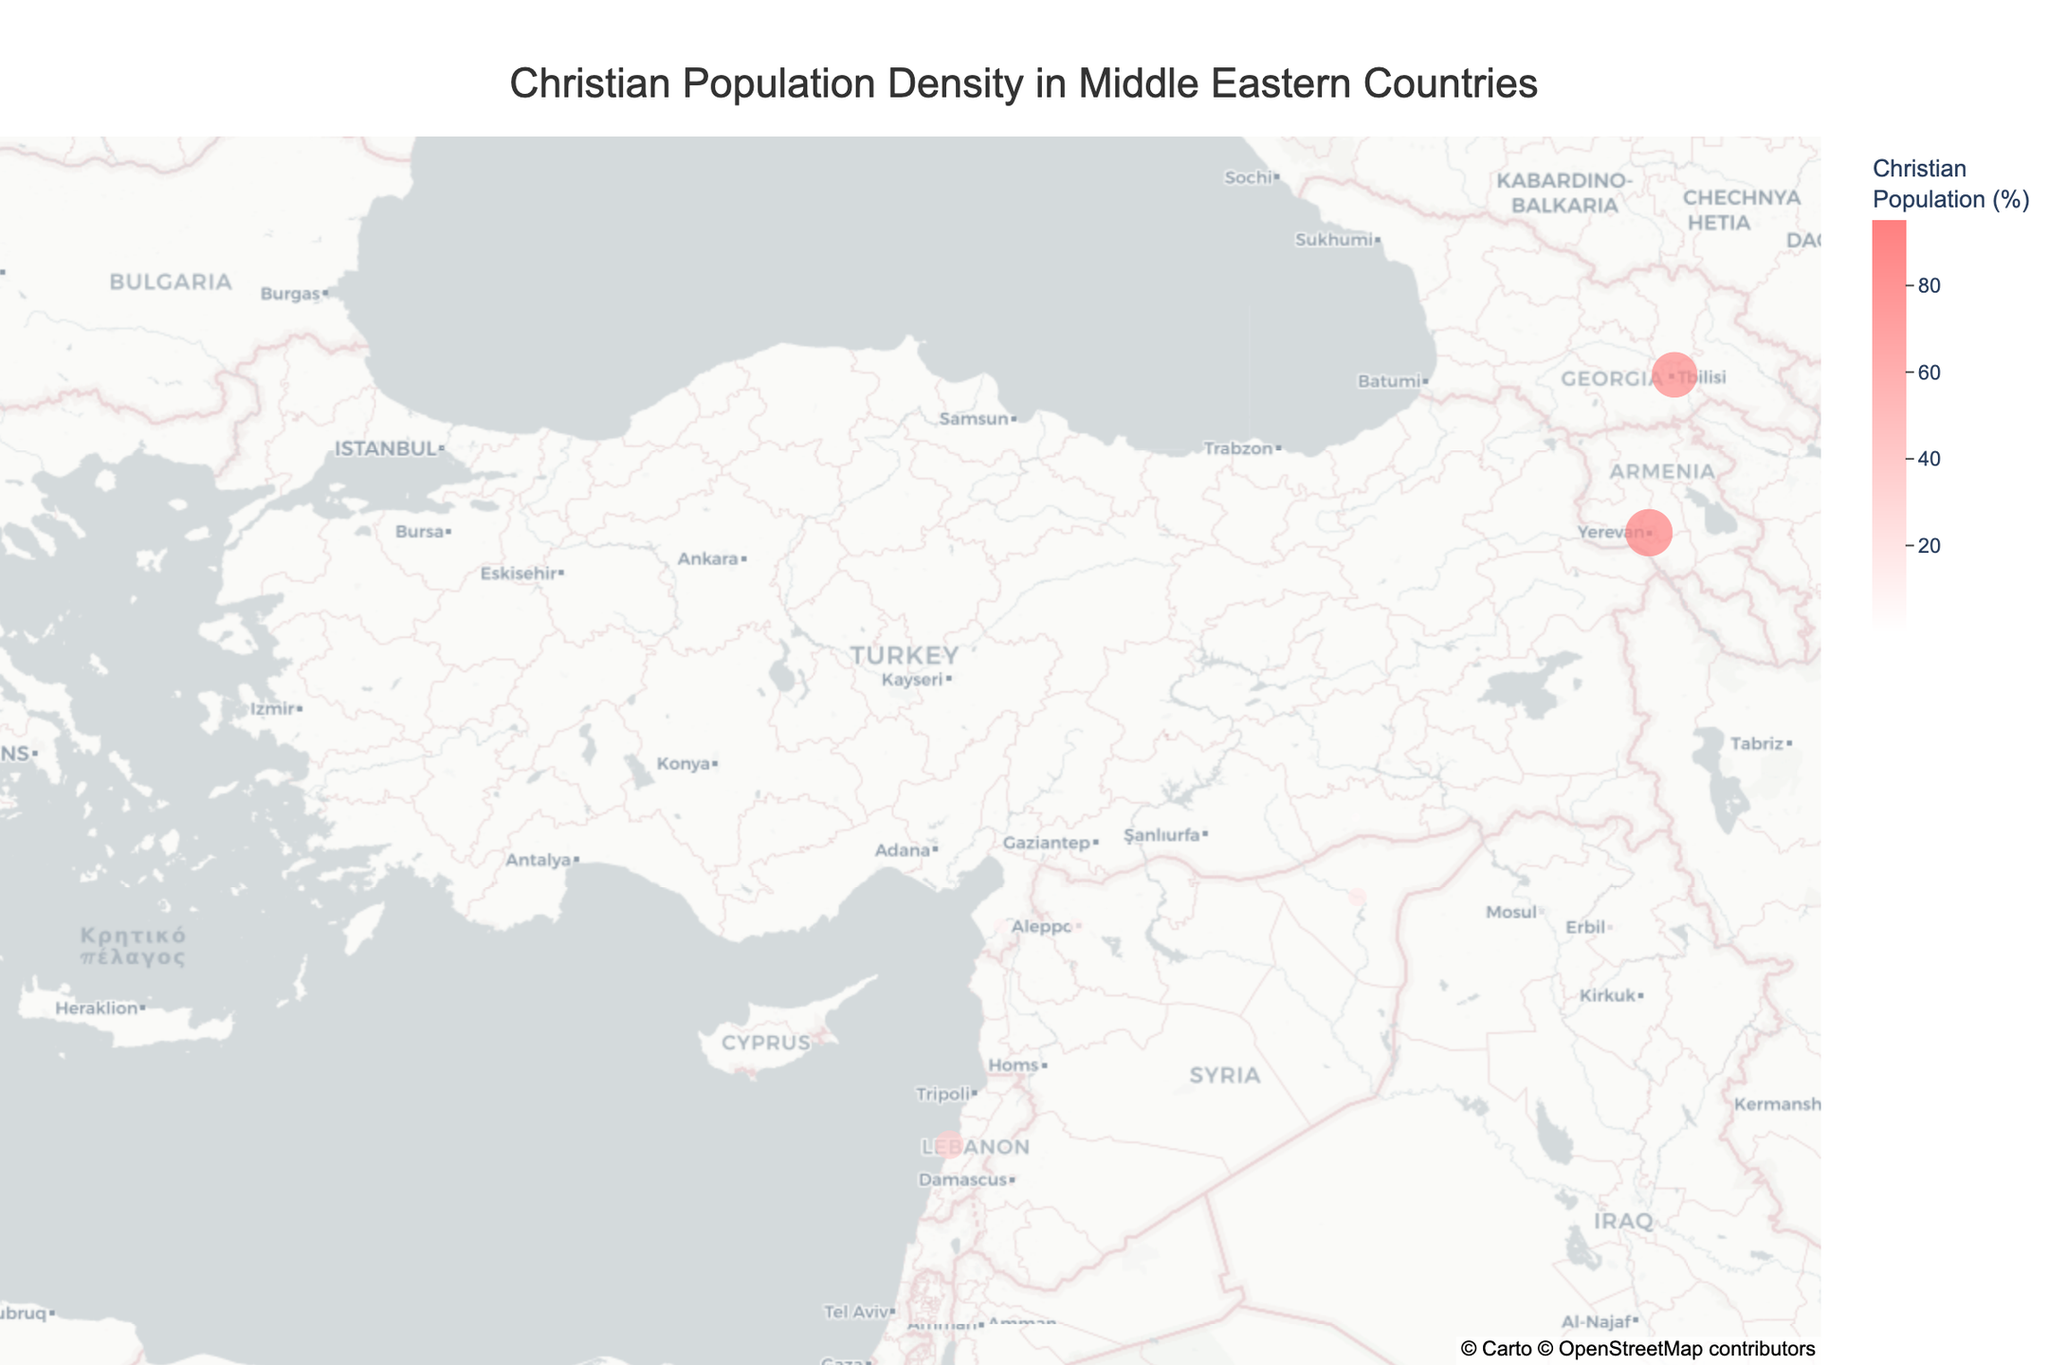How many regions in Turkey have a Christian population percentage above 1%? Look at the figure and identify the regions in Turkey. Then, check the Christian population percentages for each region. Istanbul and Diyarbakır have less than 1%, while Mardin and Hatay exceed 1%.
Answer: 2 What is the highest Christian population percentage in Turkey, and which region corresponds to it? Look at the figure and find the regions in Turkey. Then, identify the highest Christian population percentage from these regions. Hatay has the highest, at 10.2%.
Answer: 10.2% (Hatay) Which country has the region with the highest Christian population percentage, and what is that percentage? Compare the Christian population percentages across all regions in the figure. Yerevan in Armenia has the highest percentage at 94.8%.
Answer: Armenia (94.8%) How does the Christian population percentage in Beirut, Lebanon compare to Istanbul, Turkey? Identify these regions in the figure. Beirut has 35.5% and Istanbul has 0.2%. Thus, Beirut's percentage is significantly higher.
Answer: Beirut has a much higher percentage (35.5%) compared to Istanbul (0.2%) Are there any regions on the plot that have a Christian population percentage above 50%? If so, which ones? Look at the figure to identify regions. Both Yerevan, Armenia (94.8%) and Tbilisi, Georgia (88.5%) have percentages above 50%.
Answer: Yerevan and Tbilisi Which region has the largest size marker on the map indicating the highest Christian population percentage, and what is the value? Look for the largest size marker on the figure. Yerevan in Armenia, with 94.8%, has the largest size marker.
Answer: Yerevan (94.8%) What is the average Christian population percentage for the four Turkish regions shown? Sum the percentages for Istanbul (0.2), Mardin (3.5), Hatay (10.2), and Diyarbakır (0.5), then divide by 4. (0.2 + 3.5 + 10.2 + 0.5)/4 = 14.4/4 = 3.6
Answer: 3.6 Which region just across the border from Turkey has the highest percentage of Christians? Identify regions bordering Turkey. For Syria and Iraq, check Aleppo (10.5%), Al-Hasakah (15.3%), Mosul (3.2%), and Erbil (5.8%). Al-Hasakah has the highest at 15.3%.
Answer: Al-Hasakah (15.3%) What's the median Christian population percentage for all regions displayed in the figure? List the percentages (0.2, 0.5, 3.2, 3.5, 5.8, 10.2, 10.5, 15.3, 35.5, 88.5, 94.8, 95.2). Finding the median depends on the middle value or average of two middle values. With 12 values, the median is the average of the 6th and 7th values: (10.2 + 10.5)/2 = 10.35.
Answer: 10.35 Which region is located the farthest south? Determine regions using latitudes in the figure. Beirut, Lebanon, at 33.8938 is the farthest south.
Answer: Beirut 